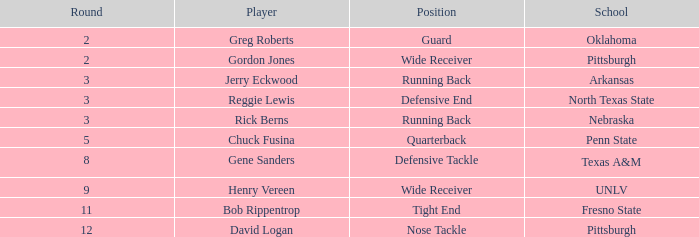What round was the nose tackle drafted? 12.0. 